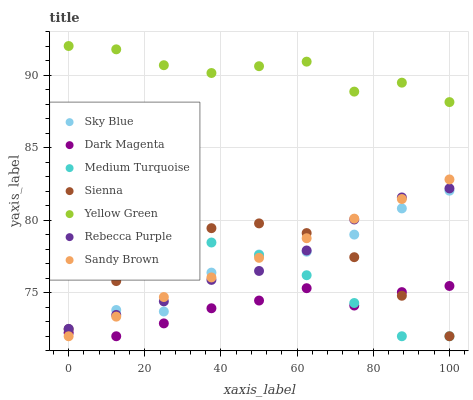Does Dark Magenta have the minimum area under the curve?
Answer yes or no. Yes. Does Yellow Green have the maximum area under the curve?
Answer yes or no. Yes. Does Sienna have the minimum area under the curve?
Answer yes or no. No. Does Sienna have the maximum area under the curve?
Answer yes or no. No. Is Sandy Brown the smoothest?
Answer yes or no. Yes. Is Yellow Green the roughest?
Answer yes or no. Yes. Is Sienna the smoothest?
Answer yes or no. No. Is Sienna the roughest?
Answer yes or no. No. Does Dark Magenta have the lowest value?
Answer yes or no. Yes. Does Rebecca Purple have the lowest value?
Answer yes or no. No. Does Yellow Green have the highest value?
Answer yes or no. Yes. Does Sienna have the highest value?
Answer yes or no. No. Is Dark Magenta less than Yellow Green?
Answer yes or no. Yes. Is Yellow Green greater than Dark Magenta?
Answer yes or no. Yes. Does Sky Blue intersect Dark Magenta?
Answer yes or no. Yes. Is Sky Blue less than Dark Magenta?
Answer yes or no. No. Is Sky Blue greater than Dark Magenta?
Answer yes or no. No. Does Dark Magenta intersect Yellow Green?
Answer yes or no. No. 